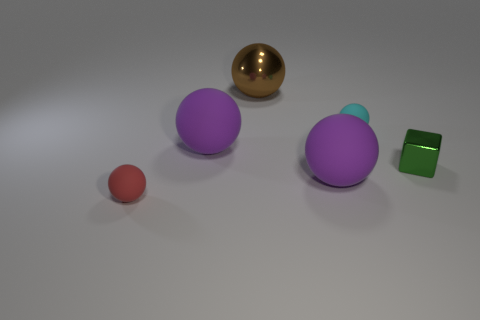How many tiny matte things have the same color as the metal block?
Your answer should be compact. 0. What number of cubes are either small yellow matte things or red matte objects?
Your answer should be very brief. 0. What is the shape of the rubber object that is in front of the green metallic cube and to the left of the large brown shiny ball?
Give a very brief answer. Sphere. Are there any cyan matte things of the same size as the metallic sphere?
Offer a terse response. No. What number of things are matte objects that are behind the small red matte object or red things?
Ensure brevity in your answer.  4. Are the big brown ball and the object on the right side of the small cyan rubber sphere made of the same material?
Offer a very short reply. Yes. How many other things are the same shape as the big brown metal object?
Your response must be concise. 4. How many things are either purple spheres that are to the left of the brown object or big rubber balls left of the big metal thing?
Provide a succinct answer. 1. How many other things are the same color as the tiny shiny thing?
Offer a very short reply. 0. Is the number of small cubes in front of the brown ball less than the number of tiny cyan rubber spheres to the right of the tiny cube?
Give a very brief answer. No. 